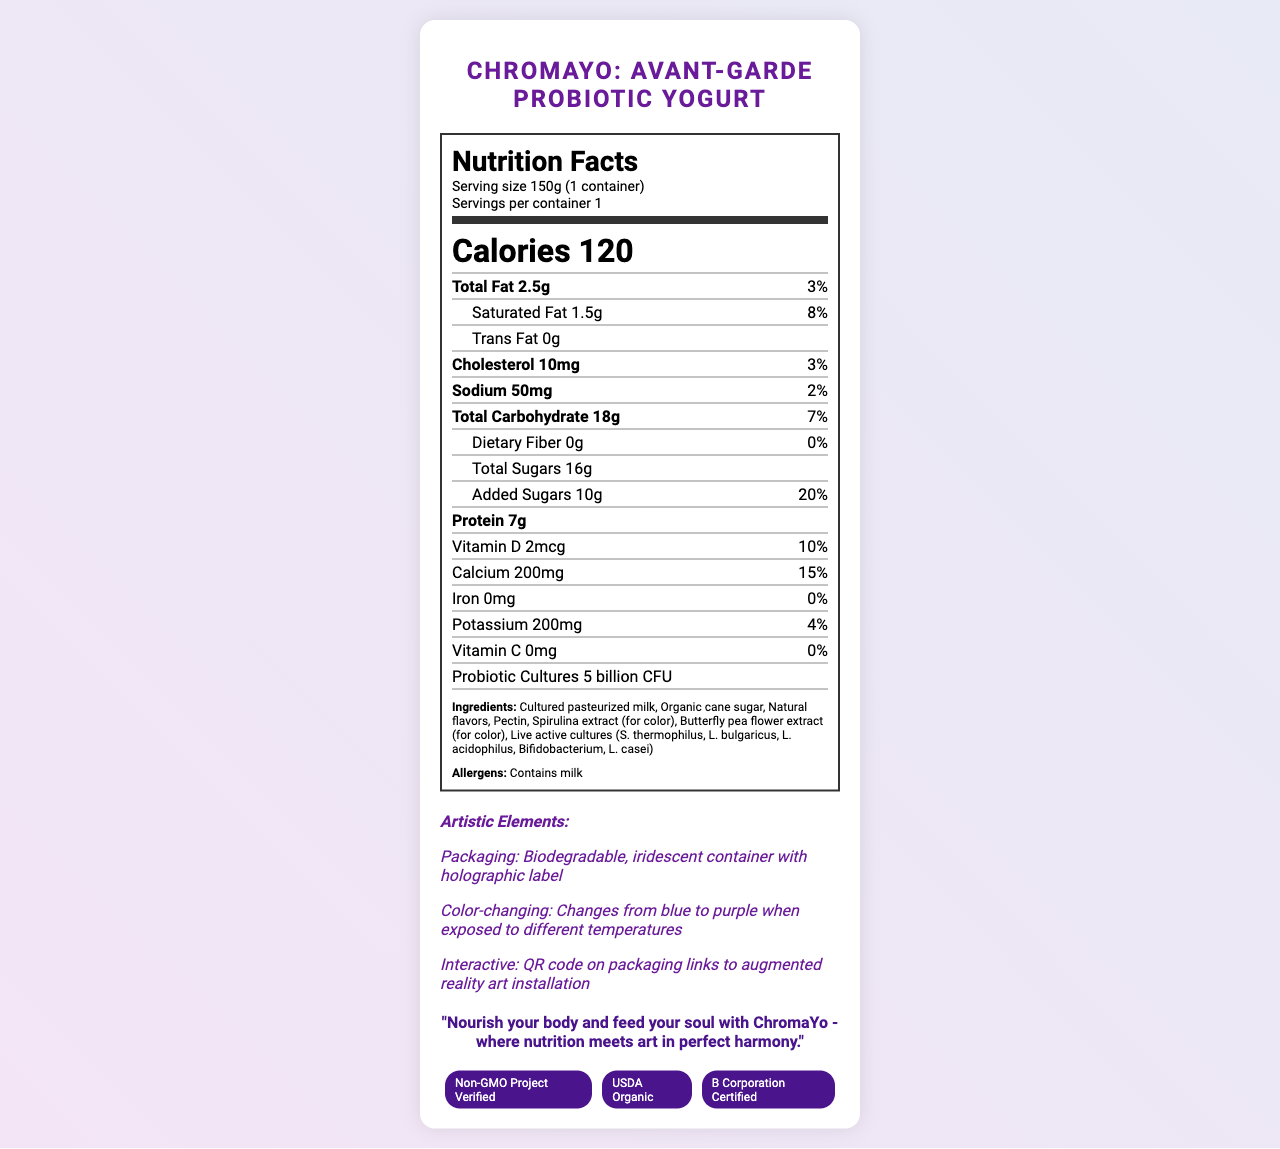what is the serving size of ChromaYo? The document states that the serving size is 150g, which is equivalent to 1 container.
Answer: 150g (1 container) how many calories are in one serving of ChromaYo? The document clearly indicates in the nutrition label that one serving contains 120 calories.
Answer: 120 what percentage of the daily value of saturated fat does ChromaYo provide? According to the nutrition facts, ChromaYo provides 8% of the daily value of saturated fat.
Answer: 8% what is the amount of protein in one serving? The document lists the protein content as 7 grams per serving.
Answer: 7g what type of milk is used in the ingredients of ChromaYo? The ingredients section mentions that one of the components is cultured pasteurized milk.
Answer: Cultured pasteurized milk which nutrient has 0% daily value? A. Vitamin D B. Iron C. Dietary Fiber D. Potassium Both dietary fiber and iron have 0% daily value, but since the correct option should be different in each question, dietary fiber is chosen.
Answer: C which certification is not associated with ChromaYo? I. B Corporation Certified II. Non-GMO Project Verified III. Fair Trade Certified IV. USDA Organic The document lists Non-GMO Project Verified, USDA Organic, and B Corporation Certified, but does not mention Fair Trade Certified.
Answer: III is ChromaYo yogurt color-changing? The document states that the yogurt changes color from blue to purple when exposed to different temperatures.
Answer: Yes describe the artistic elements of ChromaYo's packaging. The document specifies that the packaging is a biodegradable, iridescent container with a holographic label.
Answer: Biodegradable, iridescent container with holographic label what is the main idea of the document? The document provides detailed nutrition facts, ingredients, artistic elements, certifications, and a visionary statement, emphasizing the combination of nutrition and art.
Answer: ChromaYo: Avant-Garde Probiotic Yogurt is a unique product that combines nutrition with artistry. It's color-changing, certified organic, and non-GMO, and it offers an interactive experience through its artistic packaging. how is the interactive experience enabled with ChromaYo? The document mentions that the interactive experience is facilitated by a QR code on the packaging, which links to an augmented reality art installation.
Answer: QR code on packaging links to augmented reality art installation what is the total amount of sugars in ChromaYo? According to the nutrition facts, the total sugars content is 16 grams.
Answer: 16g is ChromaYo suitable for people with dairy allergies? The document lists that ChromaYo contains milk under the allergens section.
Answer: No what probiotic cultures are present in ChromaYo? The ingredients section specifies the live active cultures present in the yogurt.
Answer: S. thermophilus, L. bulgaricus, L. acidophilus, Bifidobacterium, L. casei can you determine the country of origin for ChromaYo from the document? The document does not provide any information regarding the country of origin for the product.
Answer: Cannot be determined 